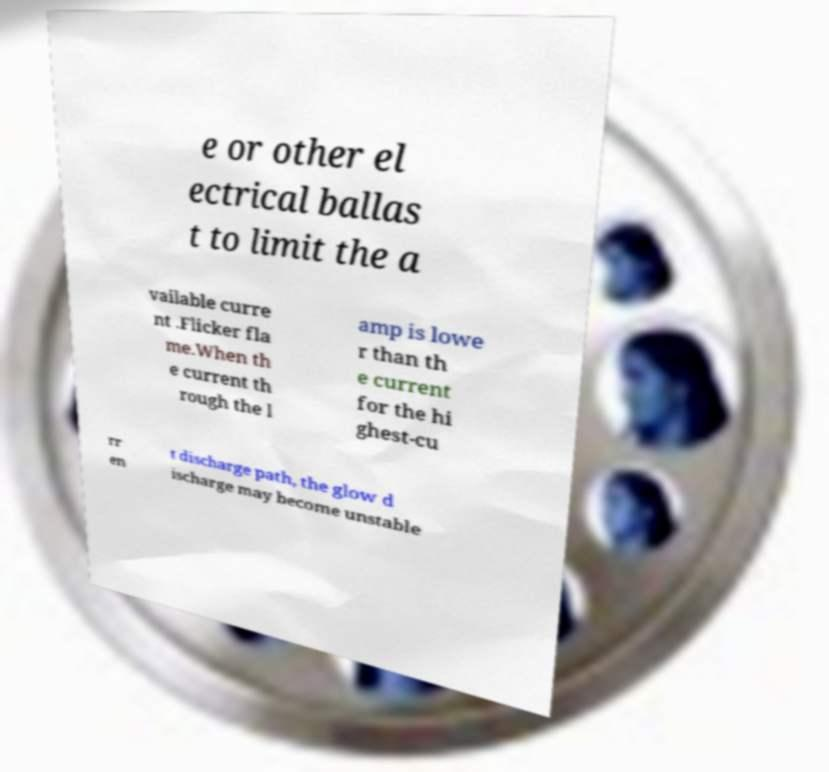For documentation purposes, I need the text within this image transcribed. Could you provide that? e or other el ectrical ballas t to limit the a vailable curre nt .Flicker fla me.When th e current th rough the l amp is lowe r than th e current for the hi ghest-cu rr en t discharge path, the glow d ischarge may become unstable 